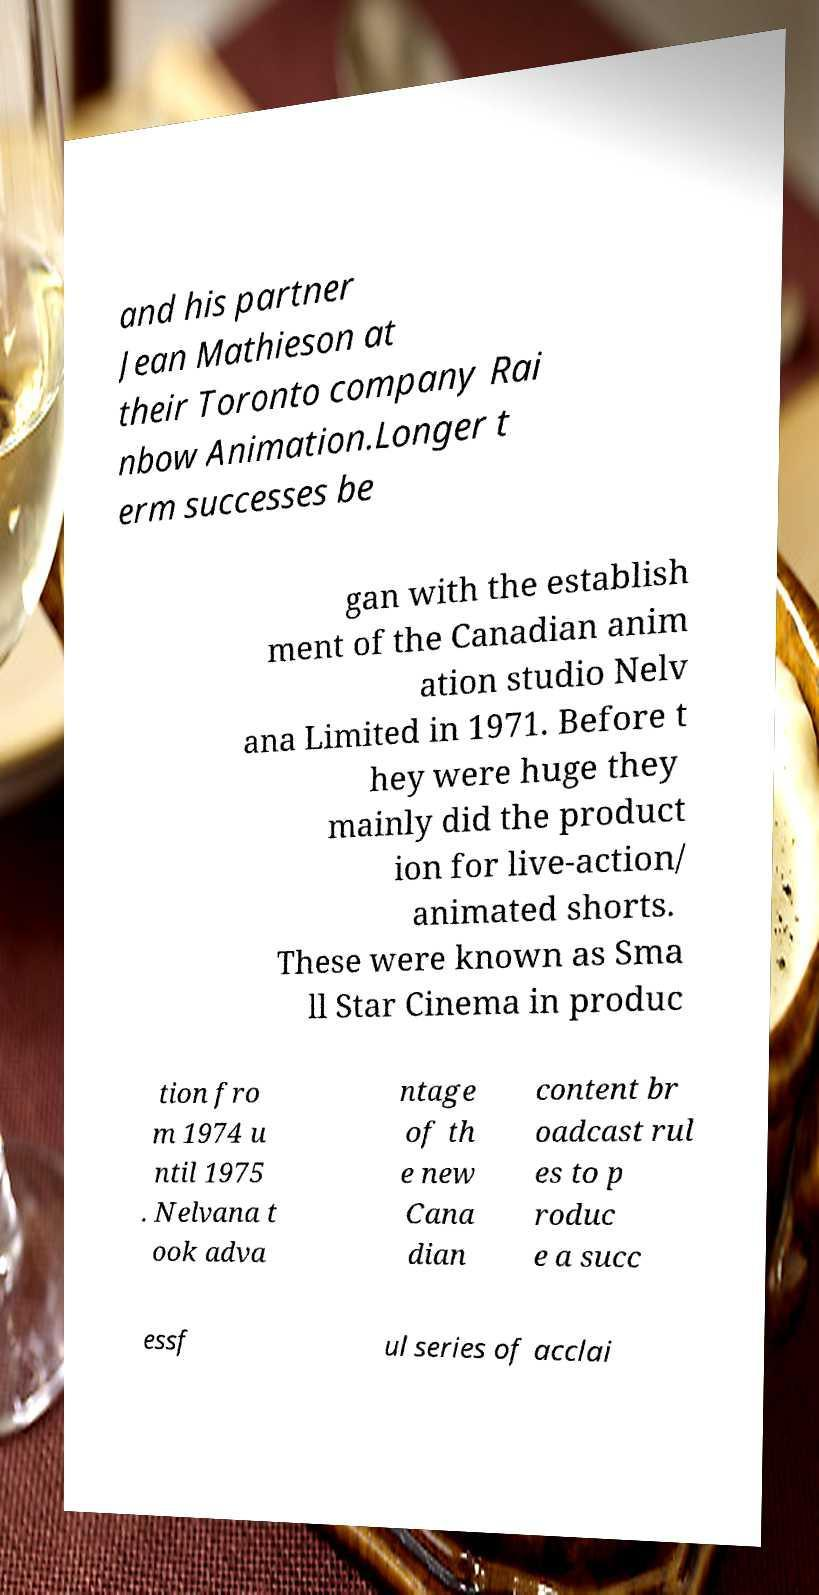Could you assist in decoding the text presented in this image and type it out clearly? and his partner Jean Mathieson at their Toronto company Rai nbow Animation.Longer t erm successes be gan with the establish ment of the Canadian anim ation studio Nelv ana Limited in 1971. Before t hey were huge they mainly did the product ion for live-action/ animated shorts. These were known as Sma ll Star Cinema in produc tion fro m 1974 u ntil 1975 . Nelvana t ook adva ntage of th e new Cana dian content br oadcast rul es to p roduc e a succ essf ul series of acclai 